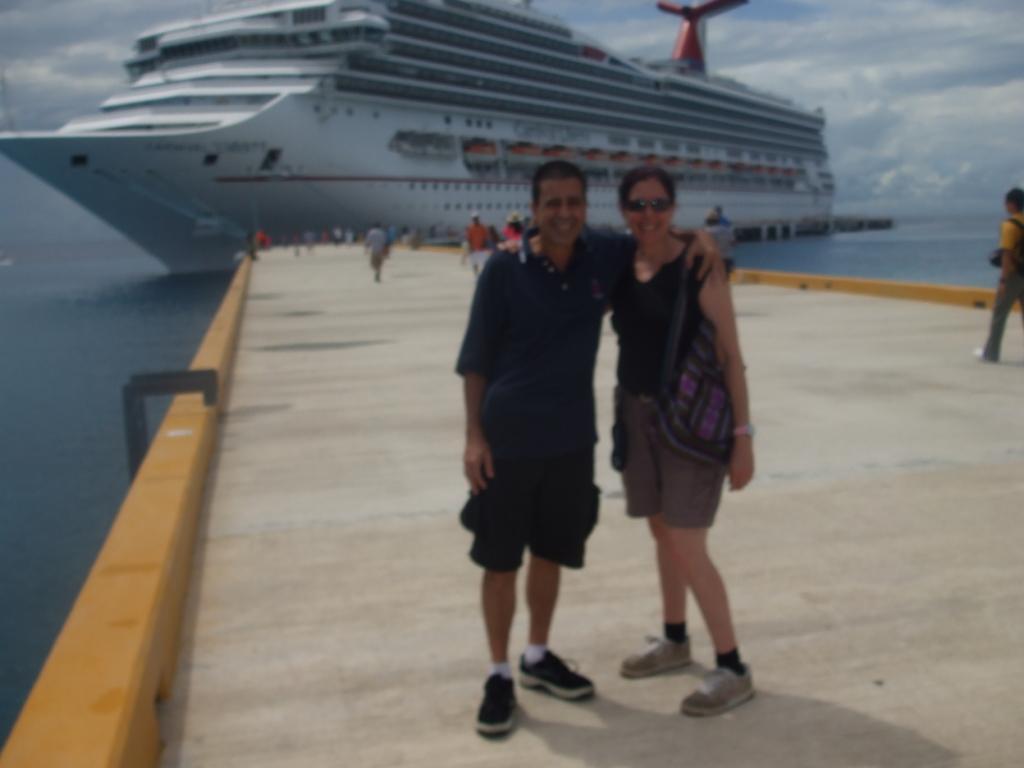How would you summarize this image in a sentence or two? In this image on the foreground on the path there is a ship on the water body. The sky is cloudy. 